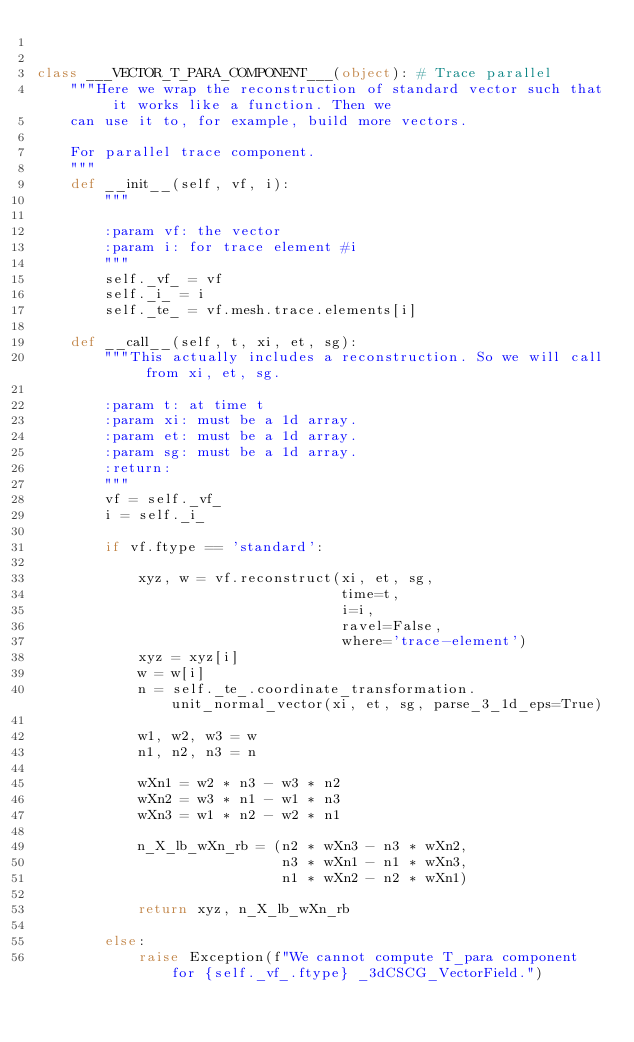<code> <loc_0><loc_0><loc_500><loc_500><_Python_>

class ___VECTOR_T_PARA_COMPONENT___(object): # Trace parallel
    """Here we wrap the reconstruction of standard vector such that it works like a function. Then we
    can use it to, for example, build more vectors.

    For parallel trace component.
    """
    def __init__(self, vf, i):
        """

        :param vf: the vector
        :param i: for trace element #i
        """
        self._vf_ = vf
        self._i_ = i
        self._te_ = vf.mesh.trace.elements[i]

    def __call__(self, t, xi, et, sg):
        """This actually includes a reconstruction. So we will call from xi, et, sg.

        :param t: at time t
        :param xi: must be a 1d array.
        :param et: must be a 1d array.
        :param sg: must be a 1d array.
        :return:
        """
        vf = self._vf_
        i = self._i_

        if vf.ftype == 'standard':

            xyz, w = vf.reconstruct(xi, et, sg,
                                    time=t,
                                    i=i,
                                    ravel=False,
                                    where='trace-element')
            xyz = xyz[i]
            w = w[i]
            n = self._te_.coordinate_transformation.unit_normal_vector(xi, et, sg, parse_3_1d_eps=True)

            w1, w2, w3 = w
            n1, n2, n3 = n

            wXn1 = w2 * n3 - w3 * n2
            wXn2 = w3 * n1 - w1 * n3
            wXn3 = w1 * n2 - w2 * n1

            n_X_lb_wXn_rb = (n2 * wXn3 - n3 * wXn2,
                             n3 * wXn1 - n1 * wXn3,
                             n1 * wXn2 - n2 * wXn1)

            return xyz, n_X_lb_wXn_rb

        else:
            raise Exception(f"We cannot compute T_para component for {self._vf_.ftype} _3dCSCG_VectorField.")
</code> 